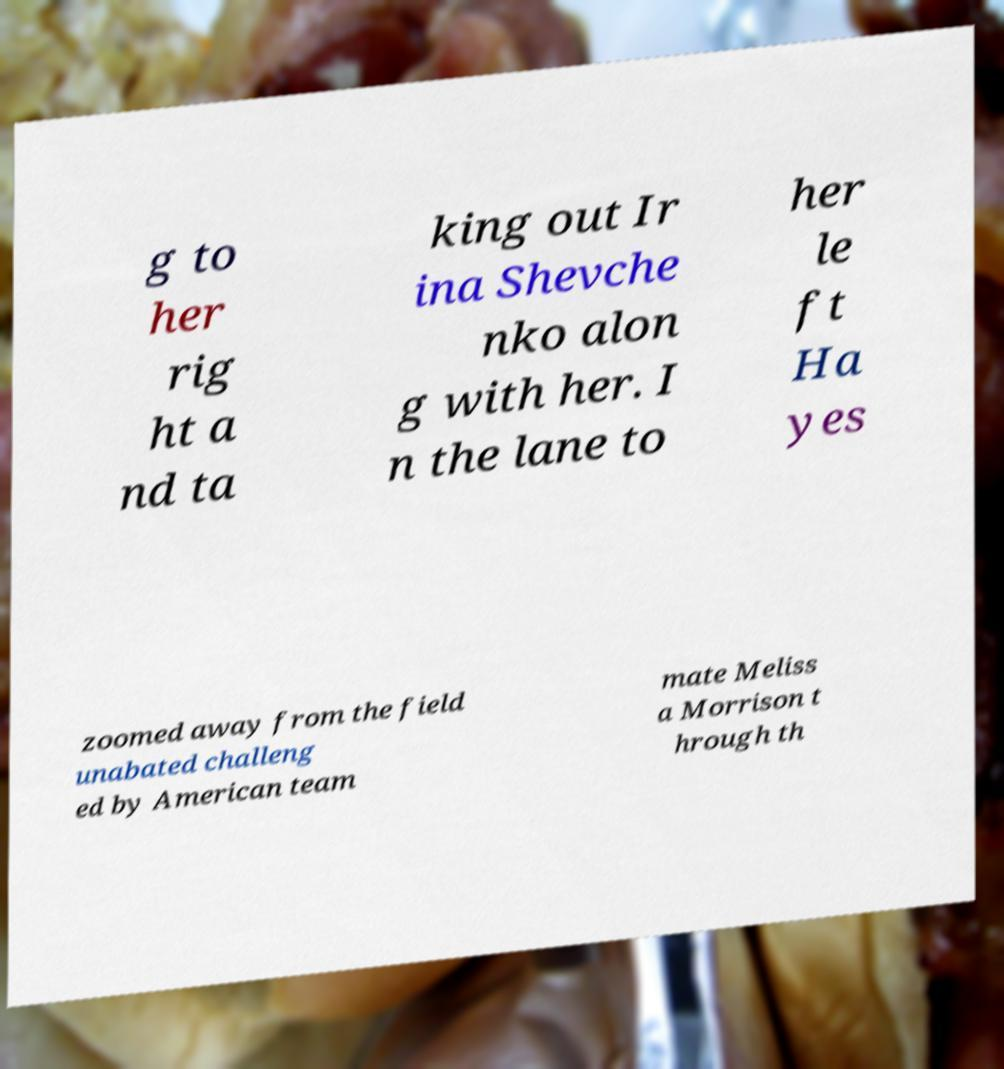Could you extract and type out the text from this image? g to her rig ht a nd ta king out Ir ina Shevche nko alon g with her. I n the lane to her le ft Ha yes zoomed away from the field unabated challeng ed by American team mate Meliss a Morrison t hrough th 